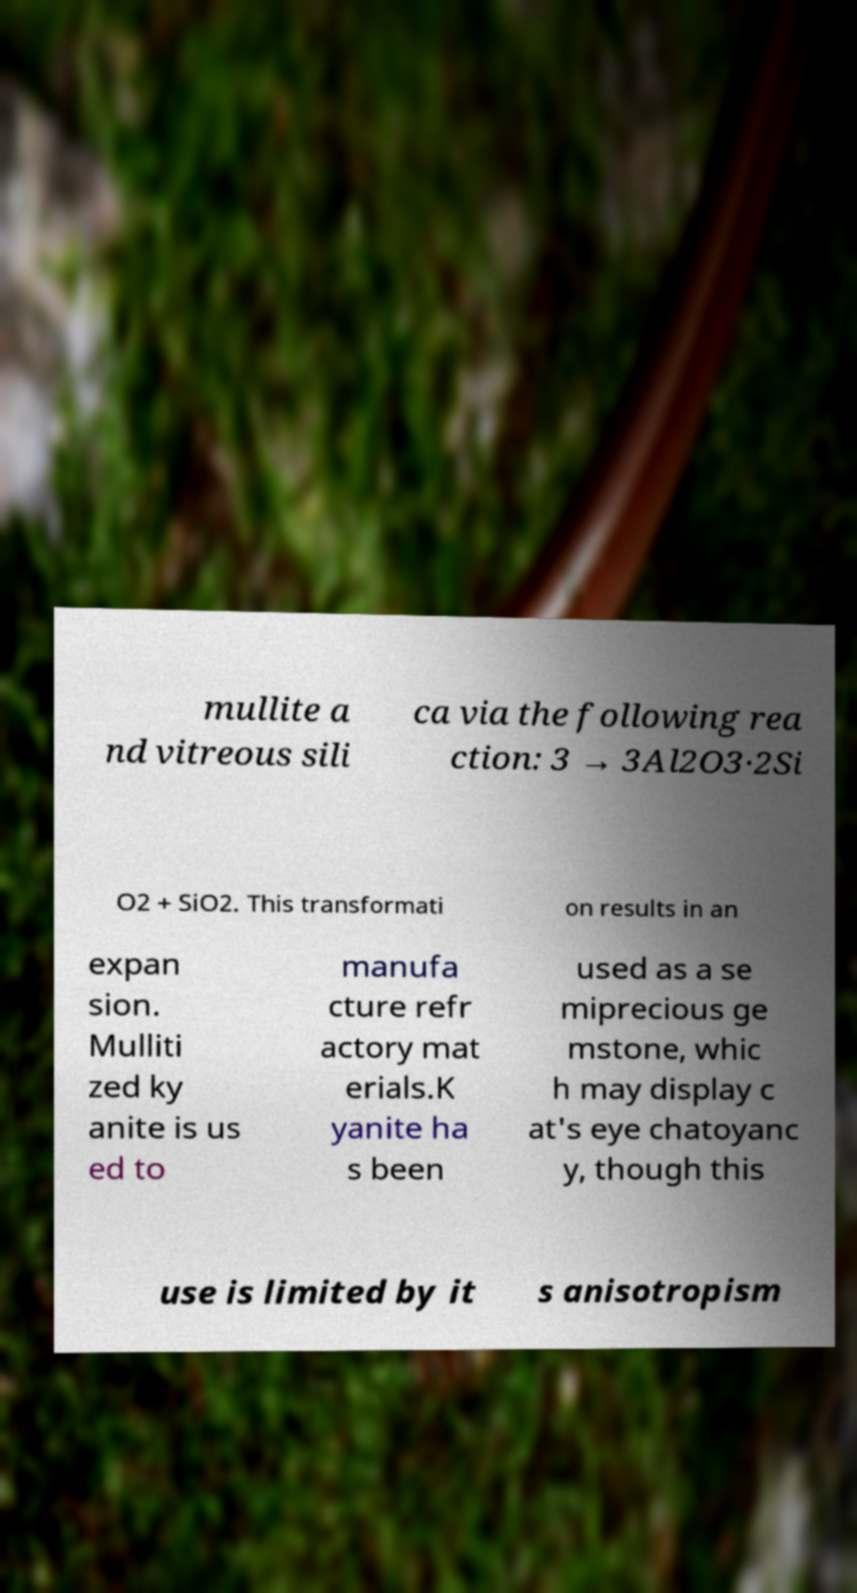I need the written content from this picture converted into text. Can you do that? mullite a nd vitreous sili ca via the following rea ction: 3 → 3Al2O3·2Si O2 + SiO2. This transformati on results in an expan sion. Mulliti zed ky anite is us ed to manufa cture refr actory mat erials.K yanite ha s been used as a se miprecious ge mstone, whic h may display c at's eye chatoyanc y, though this use is limited by it s anisotropism 